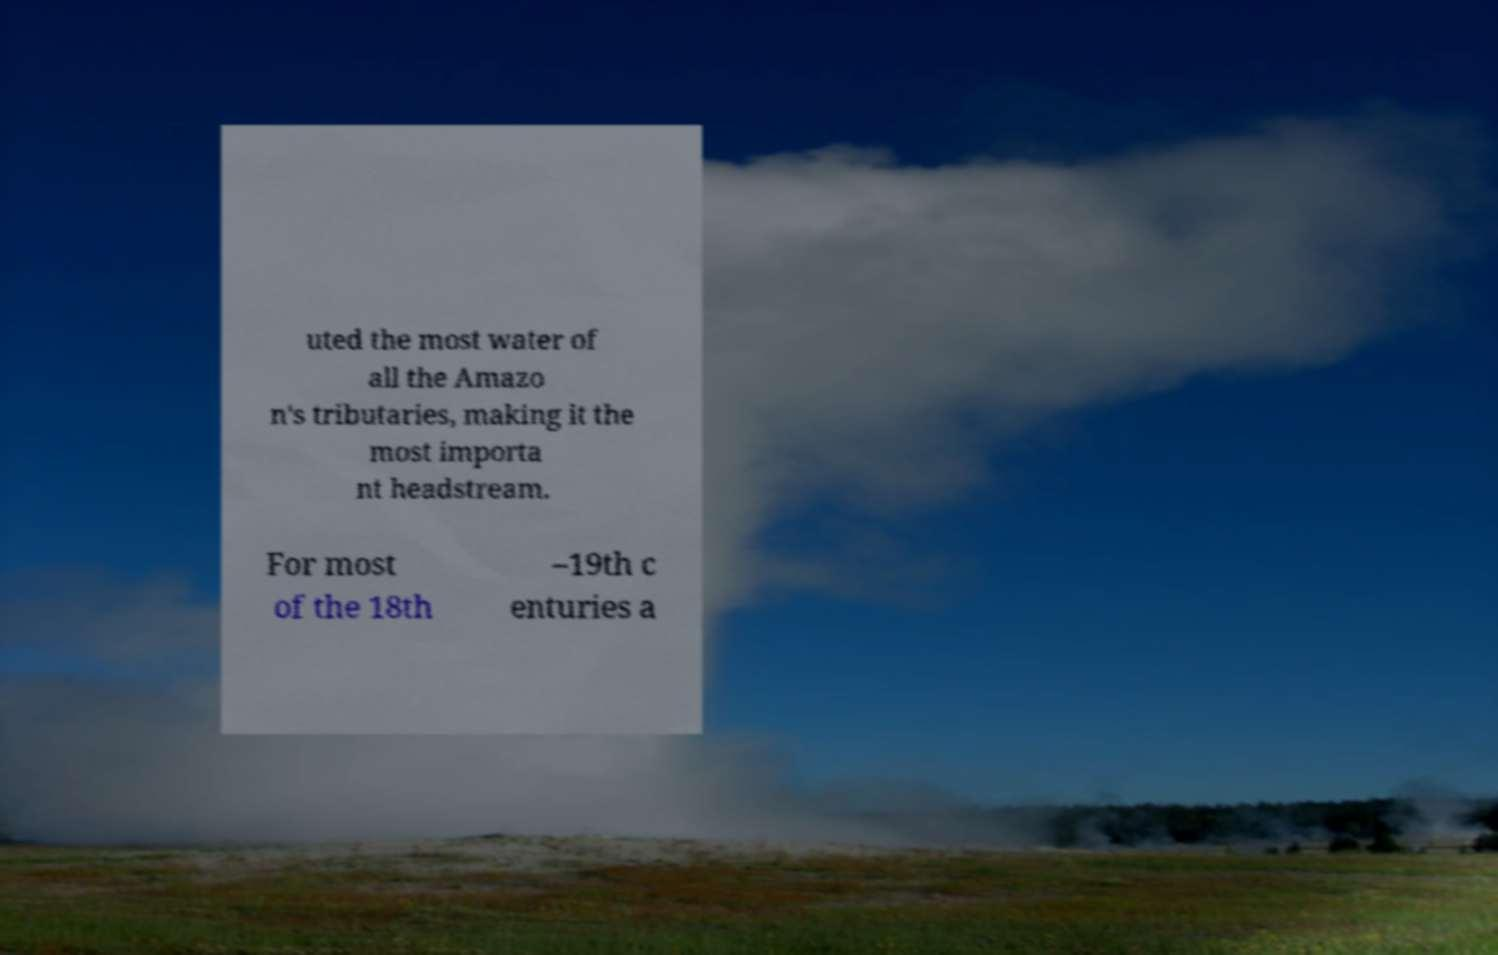Please read and relay the text visible in this image. What does it say? uted the most water of all the Amazo n's tributaries, making it the most importa nt headstream. For most of the 18th –19th c enturies a 